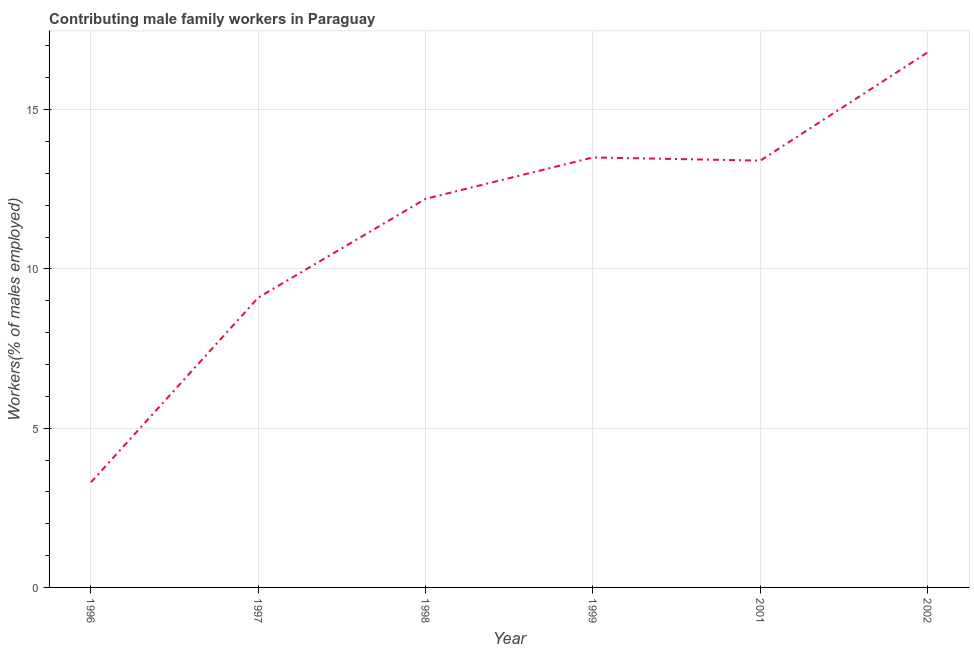What is the contributing male family workers in 1997?
Your response must be concise. 9.1. Across all years, what is the maximum contributing male family workers?
Your answer should be compact. 16.8. Across all years, what is the minimum contributing male family workers?
Provide a succinct answer. 3.3. What is the sum of the contributing male family workers?
Make the answer very short. 68.3. What is the difference between the contributing male family workers in 1997 and 2001?
Offer a terse response. -4.3. What is the average contributing male family workers per year?
Offer a terse response. 11.38. What is the median contributing male family workers?
Make the answer very short. 12.8. In how many years, is the contributing male family workers greater than 8 %?
Provide a succinct answer. 5. What is the ratio of the contributing male family workers in 1996 to that in 1999?
Your answer should be compact. 0.24. Is the difference between the contributing male family workers in 1997 and 1999 greater than the difference between any two years?
Give a very brief answer. No. What is the difference between the highest and the second highest contributing male family workers?
Provide a short and direct response. 3.3. Is the sum of the contributing male family workers in 1997 and 1998 greater than the maximum contributing male family workers across all years?
Keep it short and to the point. Yes. What is the difference between the highest and the lowest contributing male family workers?
Give a very brief answer. 13.5. What is the title of the graph?
Provide a short and direct response. Contributing male family workers in Paraguay. What is the label or title of the Y-axis?
Give a very brief answer. Workers(% of males employed). What is the Workers(% of males employed) of 1996?
Your response must be concise. 3.3. What is the Workers(% of males employed) in 1997?
Your answer should be compact. 9.1. What is the Workers(% of males employed) of 1998?
Provide a short and direct response. 12.2. What is the Workers(% of males employed) in 2001?
Your answer should be very brief. 13.4. What is the Workers(% of males employed) of 2002?
Provide a succinct answer. 16.8. What is the difference between the Workers(% of males employed) in 1996 and 1997?
Offer a terse response. -5.8. What is the difference between the Workers(% of males employed) in 1996 and 2001?
Your answer should be very brief. -10.1. What is the difference between the Workers(% of males employed) in 1996 and 2002?
Offer a very short reply. -13.5. What is the difference between the Workers(% of males employed) in 1997 and 1999?
Keep it short and to the point. -4.4. What is the difference between the Workers(% of males employed) in 1997 and 2001?
Keep it short and to the point. -4.3. What is the difference between the Workers(% of males employed) in 1997 and 2002?
Provide a short and direct response. -7.7. What is the difference between the Workers(% of males employed) in 1998 and 1999?
Ensure brevity in your answer.  -1.3. What is the difference between the Workers(% of males employed) in 1998 and 2001?
Offer a terse response. -1.2. What is the difference between the Workers(% of males employed) in 1998 and 2002?
Ensure brevity in your answer.  -4.6. What is the difference between the Workers(% of males employed) in 2001 and 2002?
Your answer should be very brief. -3.4. What is the ratio of the Workers(% of males employed) in 1996 to that in 1997?
Offer a very short reply. 0.36. What is the ratio of the Workers(% of males employed) in 1996 to that in 1998?
Offer a terse response. 0.27. What is the ratio of the Workers(% of males employed) in 1996 to that in 1999?
Ensure brevity in your answer.  0.24. What is the ratio of the Workers(% of males employed) in 1996 to that in 2001?
Your response must be concise. 0.25. What is the ratio of the Workers(% of males employed) in 1996 to that in 2002?
Give a very brief answer. 0.2. What is the ratio of the Workers(% of males employed) in 1997 to that in 1998?
Offer a terse response. 0.75. What is the ratio of the Workers(% of males employed) in 1997 to that in 1999?
Ensure brevity in your answer.  0.67. What is the ratio of the Workers(% of males employed) in 1997 to that in 2001?
Your answer should be very brief. 0.68. What is the ratio of the Workers(% of males employed) in 1997 to that in 2002?
Keep it short and to the point. 0.54. What is the ratio of the Workers(% of males employed) in 1998 to that in 1999?
Keep it short and to the point. 0.9. What is the ratio of the Workers(% of males employed) in 1998 to that in 2001?
Provide a short and direct response. 0.91. What is the ratio of the Workers(% of males employed) in 1998 to that in 2002?
Keep it short and to the point. 0.73. What is the ratio of the Workers(% of males employed) in 1999 to that in 2002?
Provide a short and direct response. 0.8. What is the ratio of the Workers(% of males employed) in 2001 to that in 2002?
Ensure brevity in your answer.  0.8. 